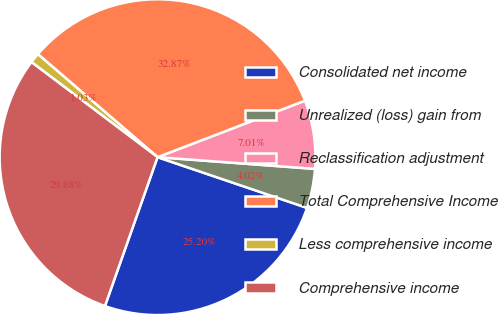<chart> <loc_0><loc_0><loc_500><loc_500><pie_chart><fcel>Consolidated net income<fcel>Unrealized (loss) gain from<fcel>Reclassification adjustment<fcel>Total Comprehensive Income<fcel>Less comprehensive income<fcel>Comprehensive income<nl><fcel>25.2%<fcel>4.02%<fcel>7.01%<fcel>32.87%<fcel>1.03%<fcel>29.88%<nl></chart> 